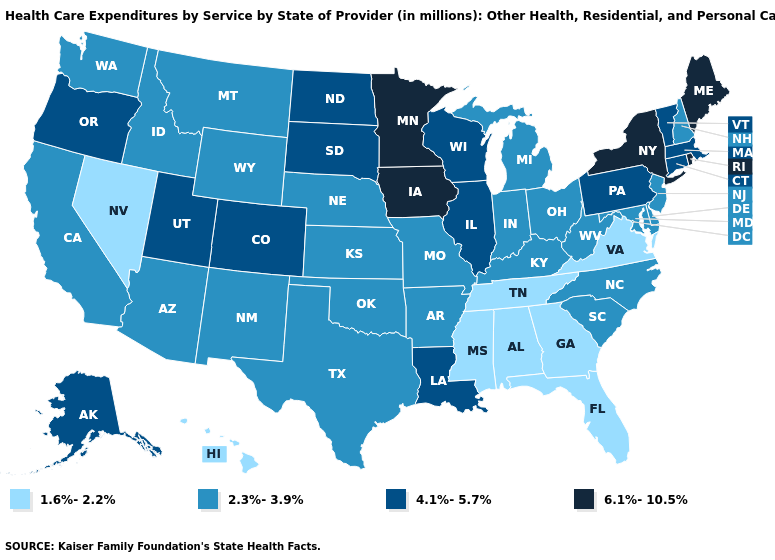Name the states that have a value in the range 2.3%-3.9%?
Answer briefly. Arizona, Arkansas, California, Delaware, Idaho, Indiana, Kansas, Kentucky, Maryland, Michigan, Missouri, Montana, Nebraska, New Hampshire, New Jersey, New Mexico, North Carolina, Ohio, Oklahoma, South Carolina, Texas, Washington, West Virginia, Wyoming. Does Vermont have the highest value in the Northeast?
Write a very short answer. No. Does Texas have a lower value than Minnesota?
Give a very brief answer. Yes. Name the states that have a value in the range 6.1%-10.5%?
Keep it brief. Iowa, Maine, Minnesota, New York, Rhode Island. What is the value of New Hampshire?
Keep it brief. 2.3%-3.9%. What is the lowest value in states that border North Carolina?
Short answer required. 1.6%-2.2%. What is the value of Delaware?
Answer briefly. 2.3%-3.9%. Does Oklahoma have the lowest value in the South?
Give a very brief answer. No. Does Georgia have the lowest value in the USA?
Give a very brief answer. Yes. Does Indiana have a lower value than New Jersey?
Short answer required. No. Name the states that have a value in the range 2.3%-3.9%?
Answer briefly. Arizona, Arkansas, California, Delaware, Idaho, Indiana, Kansas, Kentucky, Maryland, Michigan, Missouri, Montana, Nebraska, New Hampshire, New Jersey, New Mexico, North Carolina, Ohio, Oklahoma, South Carolina, Texas, Washington, West Virginia, Wyoming. Name the states that have a value in the range 2.3%-3.9%?
Be succinct. Arizona, Arkansas, California, Delaware, Idaho, Indiana, Kansas, Kentucky, Maryland, Michigan, Missouri, Montana, Nebraska, New Hampshire, New Jersey, New Mexico, North Carolina, Ohio, Oklahoma, South Carolina, Texas, Washington, West Virginia, Wyoming. Which states have the lowest value in the USA?
Short answer required. Alabama, Florida, Georgia, Hawaii, Mississippi, Nevada, Tennessee, Virginia. Among the states that border Maine , which have the lowest value?
Concise answer only. New Hampshire. Name the states that have a value in the range 2.3%-3.9%?
Short answer required. Arizona, Arkansas, California, Delaware, Idaho, Indiana, Kansas, Kentucky, Maryland, Michigan, Missouri, Montana, Nebraska, New Hampshire, New Jersey, New Mexico, North Carolina, Ohio, Oklahoma, South Carolina, Texas, Washington, West Virginia, Wyoming. 